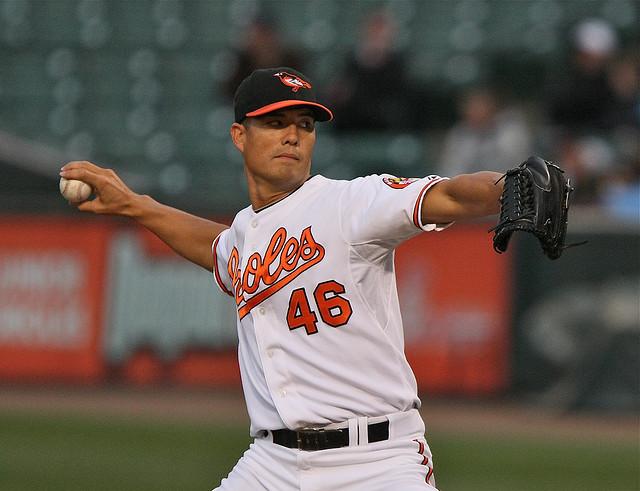What nationality is this pitcher?
Concise answer only. American. What sport is this?
Concise answer only. Baseball. He is American?
Write a very short answer. Yes. What team does this man play for?
Keep it brief. Orioles. What is the player's number?
Write a very short answer. 46. 